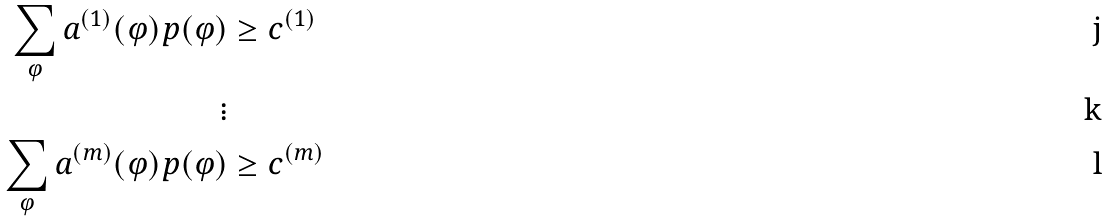<formula> <loc_0><loc_0><loc_500><loc_500>\sum _ { \varphi } a ^ { ( 1 ) } ( \varphi ) p ( \varphi ) & \geq c ^ { ( 1 ) } \\ \vdots & \\ \sum _ { \varphi } a ^ { ( m ) } ( \varphi ) p ( \varphi ) & \geq c ^ { ( m ) }</formula> 